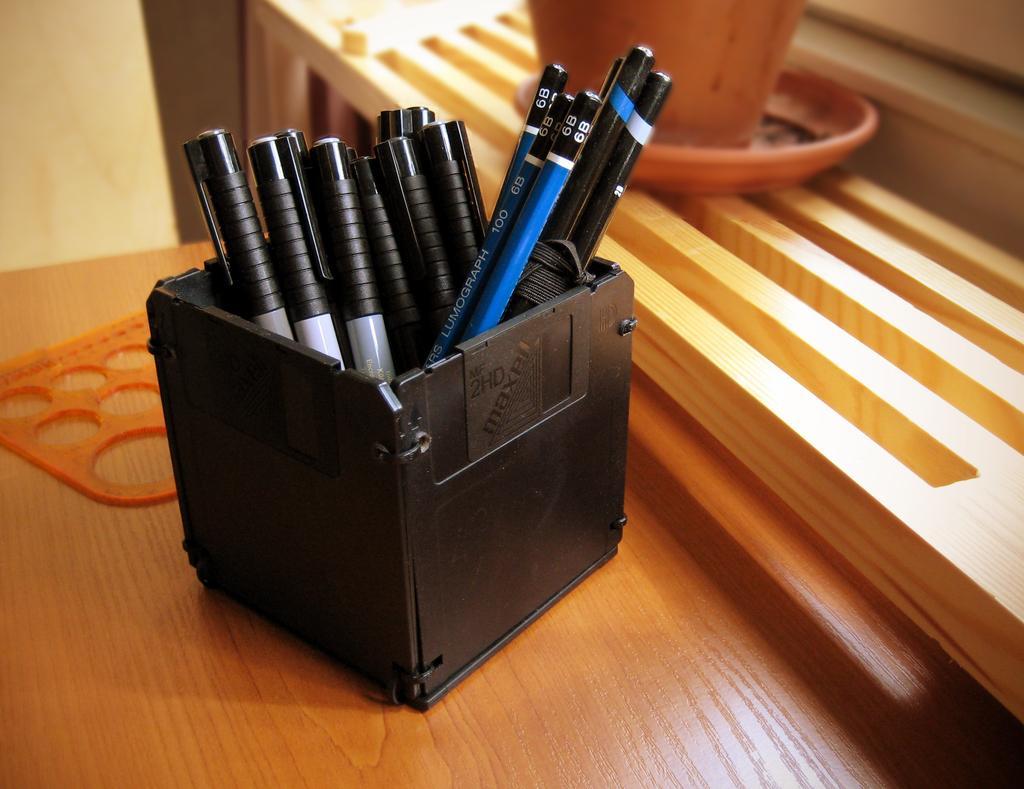Please provide a concise description of this image. In this picture we can see few pens and pencils in the box, and the box is on the table. 